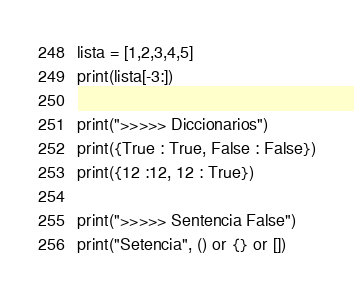<code> <loc_0><loc_0><loc_500><loc_500><_Python_>lista = [1,2,3,4,5]
print(lista[-3:])

print(">>>>> Diccionarios")
print({True : True, False : False})
print({12 :12, 12 : True})

print(">>>>> Sentencia False")
print("Setencia", () or {} or [])</code> 